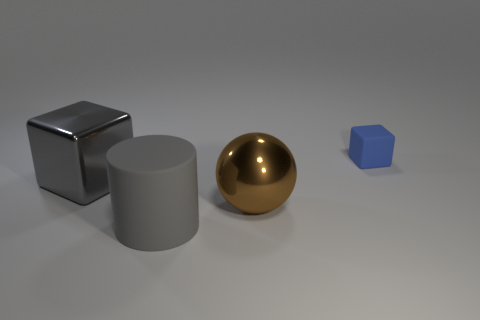Does the big shiny cube have the same color as the big matte cylinder?
Provide a short and direct response. Yes. There is a metallic object that is on the right side of the large metallic cube; is its shape the same as the gray matte object?
Provide a short and direct response. No. How many matte objects are cylinders or small blocks?
Your answer should be compact. 2. Are there any gray things that have the same material as the gray cylinder?
Your response must be concise. No. What is the material of the small blue object?
Provide a succinct answer. Rubber. There is a gray object in front of the metallic object in front of the big metal thing that is left of the big gray matte thing; what shape is it?
Keep it short and to the point. Cylinder. Is the number of objects to the right of the large block greater than the number of large purple shiny spheres?
Ensure brevity in your answer.  Yes. Is the shape of the blue object the same as the large gray object behind the large brown ball?
Provide a short and direct response. Yes. The big thing that is the same color as the metal cube is what shape?
Offer a very short reply. Cylinder. What number of metal things are in front of the metal object that is to the right of the large shiny thing that is to the left of the big gray matte object?
Give a very brief answer. 0. 